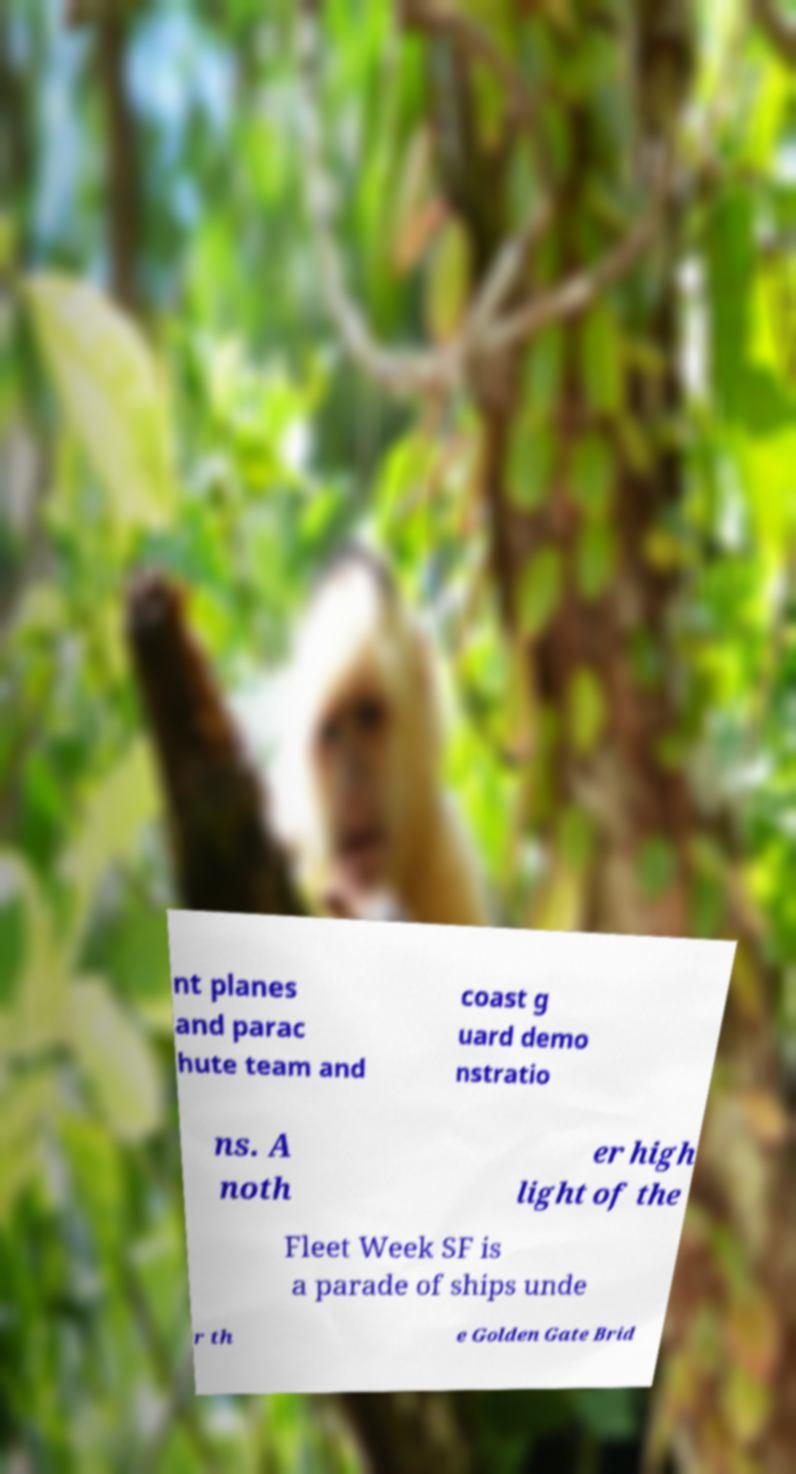Please identify and transcribe the text found in this image. nt planes and parac hute team and coast g uard demo nstratio ns. A noth er high light of the Fleet Week SF is a parade of ships unde r th e Golden Gate Brid 